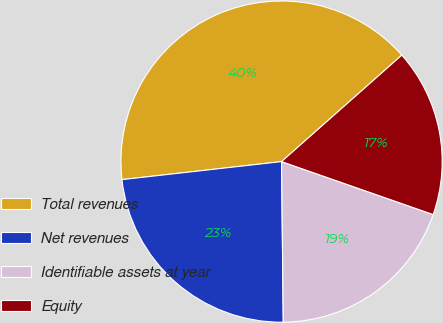<chart> <loc_0><loc_0><loc_500><loc_500><pie_chart><fcel>Total revenues<fcel>Net revenues<fcel>Identifiable assets at year<fcel>Equity<nl><fcel>40.26%<fcel>23.38%<fcel>19.48%<fcel>16.88%<nl></chart> 